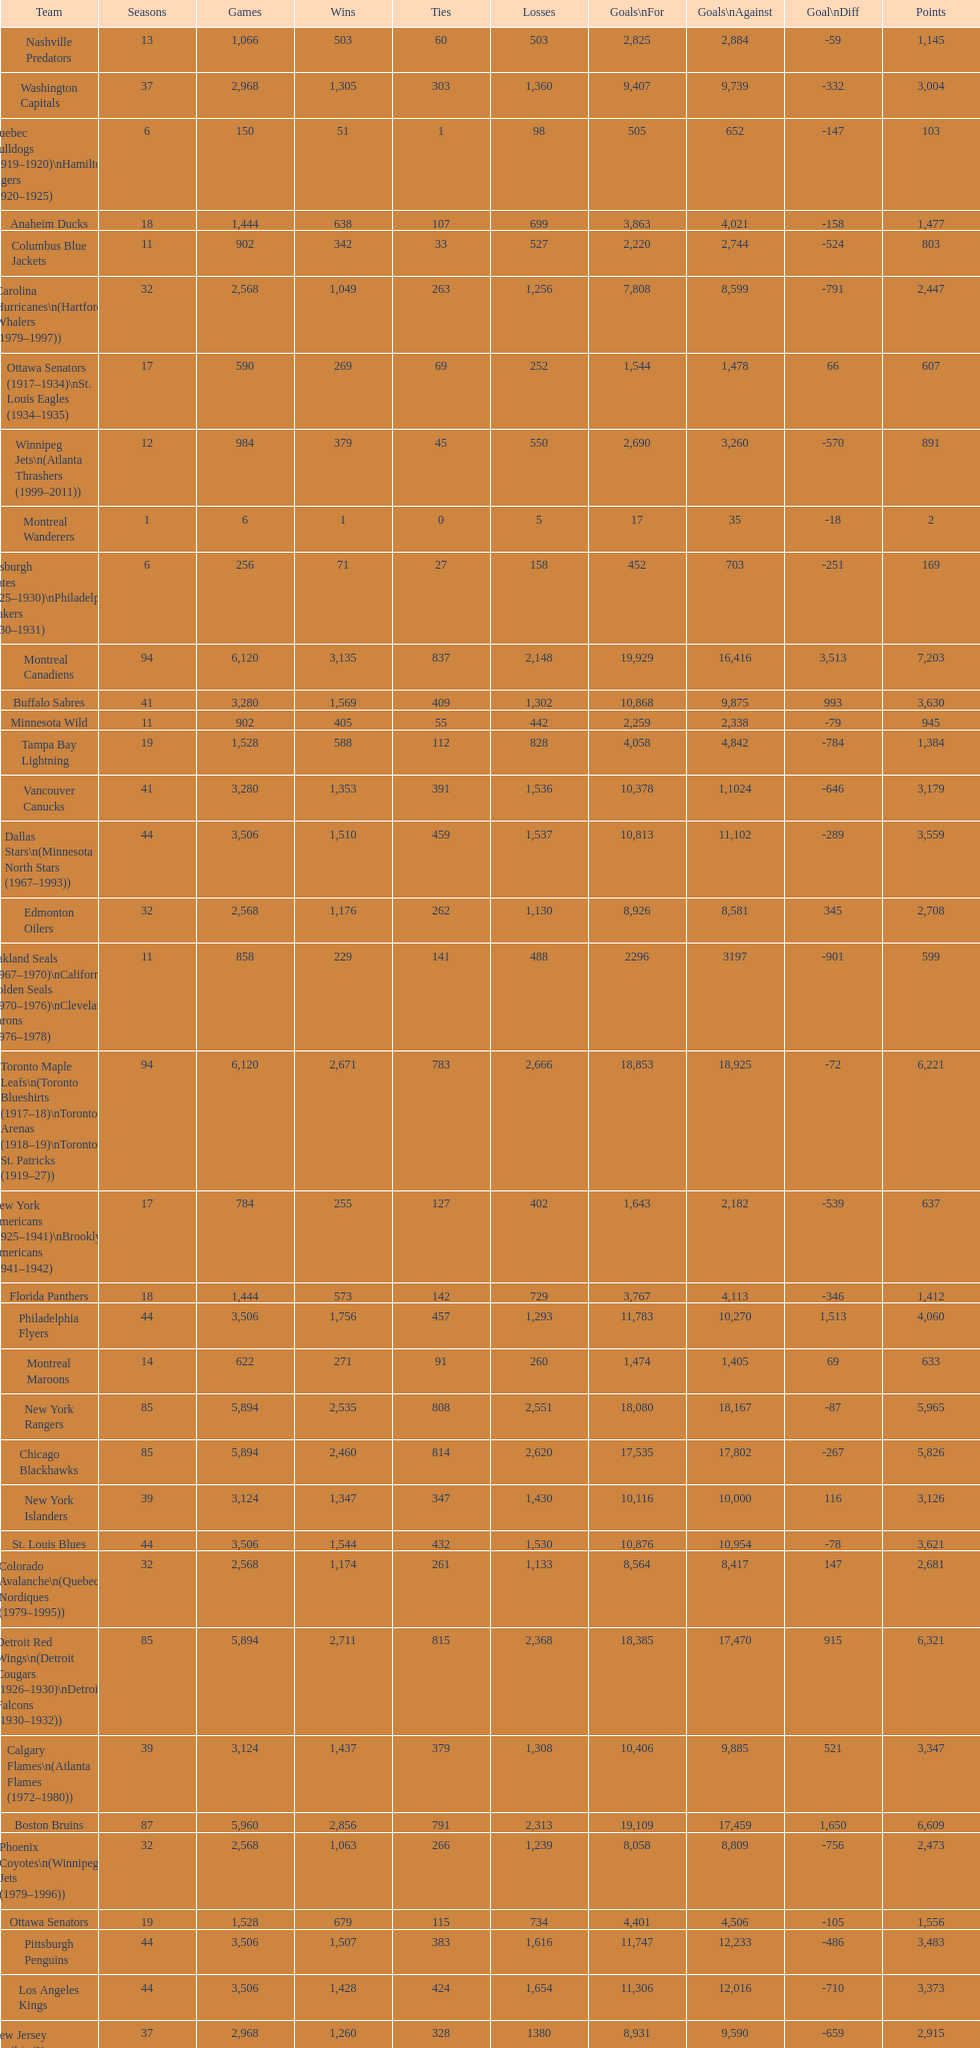What is the number of games that the vancouver canucks have won up to this point? 1,353. 